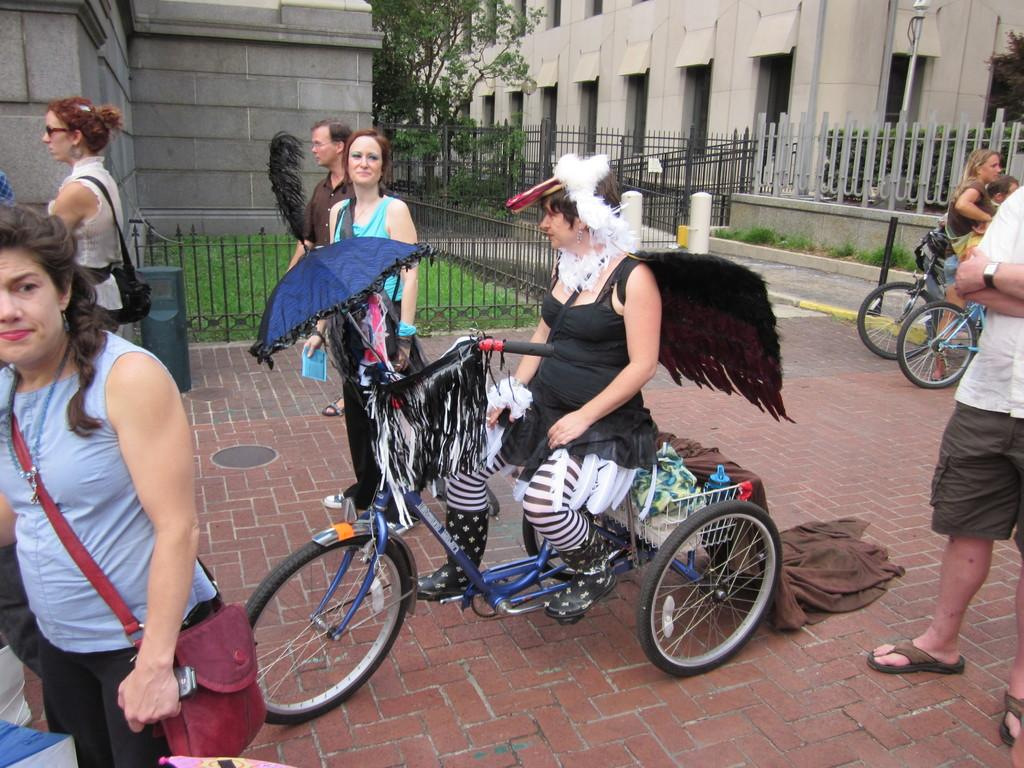What is the woman doing in the image? The woman is sitting on a vehicle. What are the people in the image doing? The people in the image are walking on the road. What can be seen in the background of the image? There is a building and a tree in the background. What type of sorting algorithm is the woman using to organize the vehicle? The image does not show the woman using any sorting algorithm; she is simply sitting on the vehicle. 